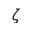Convert formula to latex. <formula><loc_0><loc_0><loc_500><loc_500>\zeta</formula> 